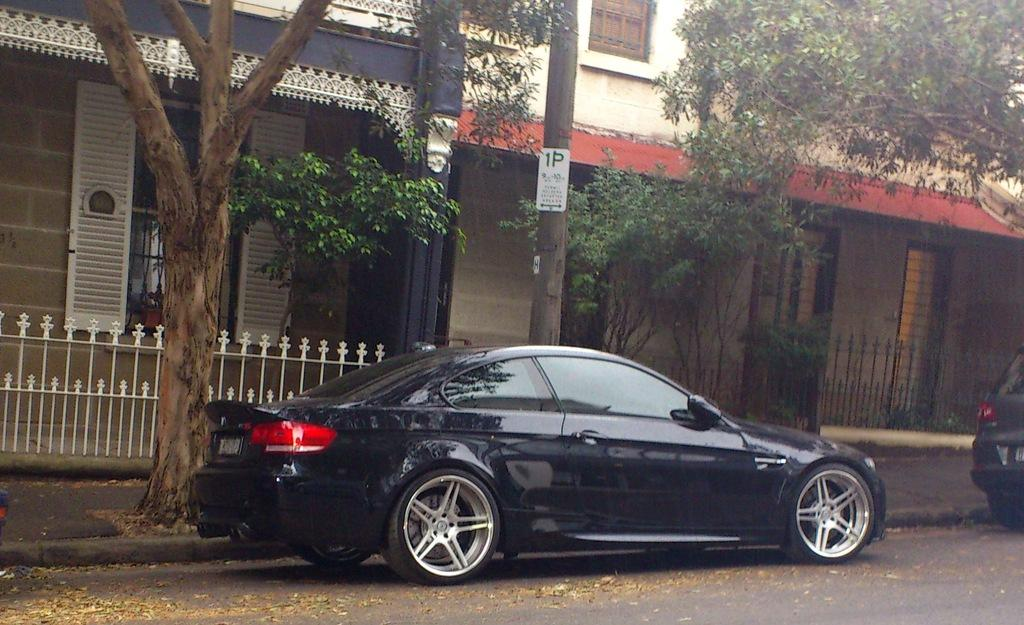What type of vehicles can be seen on the road in the image? There are cars on the road in the image. What natural elements are present in the image? There are trees in the image. What type of structures can be seen in the image? There are houses in the image. Can you see a parent holding a pipe in the image? There is no parent or pipe present in the image. Are there any cacti visible in the image? There are no cacti present in the image; only trees are mentioned. 